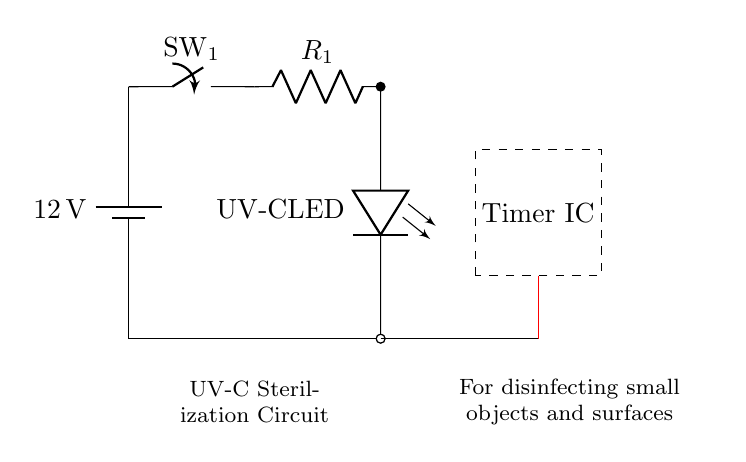What is the voltage of this circuit? The circuit shows a battery labeled with a voltage of 12 volts, indicating the potential difference used to power the circuit.
Answer: 12 volts What component is used for disinfecting? The circuit diagram prominently features a labeled component called "UV-C LED," which is designed for disinfecting by emitting UV-C light.
Answer: UV-C LED How many main components are in the circuit? Upon examining the diagram, there are four primary components: a battery, a switch, a resistor, and a UV-C LED, indicating a simple structure.
Answer: Four What function does the switch serve? The switch in the diagram is responsible for controlling the flow of current in the circuit by either allowing or interrupting the connection, which means it can turn the device on or off.
Answer: Control current flow What is the purpose of the timer IC in this circuit? The timer integrated circuit (IC) can manage the duration that the UV-C LED operates, allowing for timed disinfection, making it an essential feature for effective use.
Answer: Timed operation What is the role of the current limiting resistor? The current limiting resistor ensures that the UV-C LED receives an appropriate amount of current, preventing it from drawing too much current, which could otherwise damage the LED.
Answer: Limit current How is the circuit grounded? The grounding in the circuit is achieved by connecting the components to a common ground reference point, indicated by the short connections to the ground from the UV-C LED and upwards through the power supply.
Answer: Common ground reference 